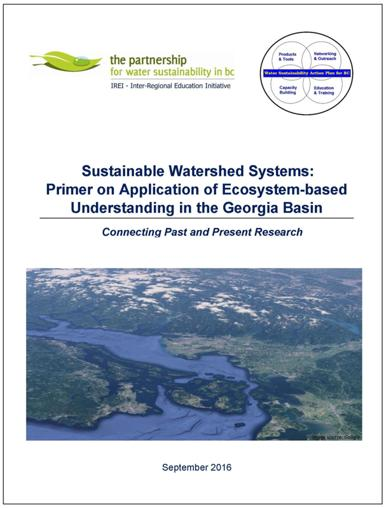What is the title of the publication mentioned in the image? The title of the publication captured in the image is 'Sustainable Watershed Systems: Primer on Application of Ecosystem-based Understanding in the Georgia Basin.' This title suggests a comprehensive approach towards watershed management and ecosystem sustainability within the Georgia Basin context. 